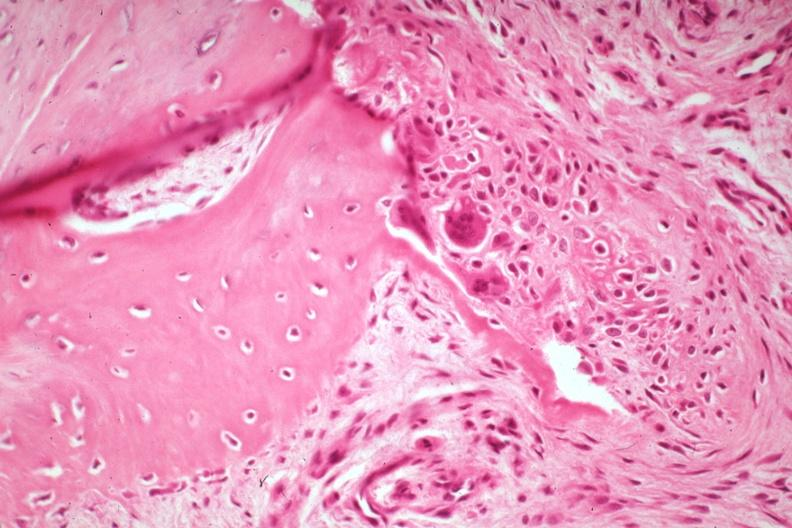what is a fracture?
Answer the question using a single word or phrase. There 